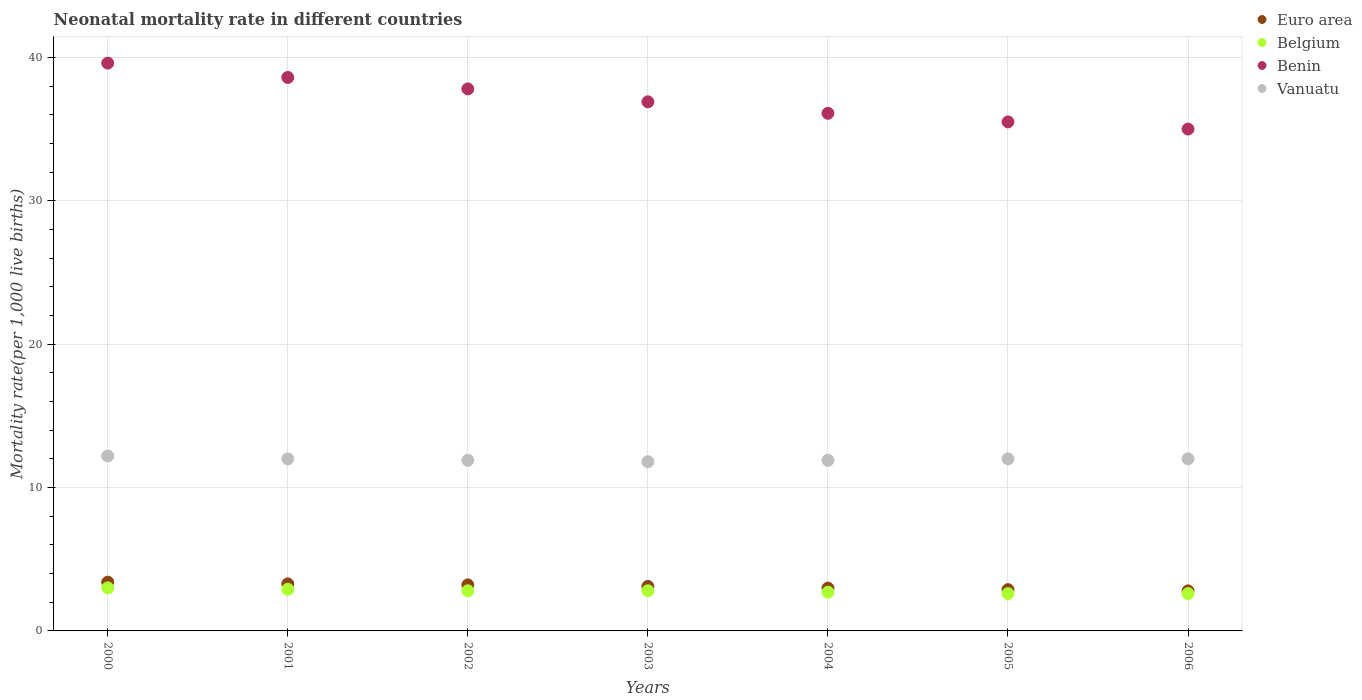What is the neonatal mortality rate in Benin in 2006?
Make the answer very short. 35. Across all years, what is the maximum neonatal mortality rate in Belgium?
Offer a terse response. 3. Across all years, what is the minimum neonatal mortality rate in Euro area?
Give a very brief answer. 2.79. What is the total neonatal mortality rate in Vanuatu in the graph?
Your answer should be compact. 83.8. What is the difference between the neonatal mortality rate in Benin in 2003 and that in 2004?
Provide a short and direct response. 0.8. What is the difference between the neonatal mortality rate in Belgium in 2004 and the neonatal mortality rate in Euro area in 2001?
Your answer should be very brief. -0.58. What is the average neonatal mortality rate in Benin per year?
Make the answer very short. 37.07. In the year 2002, what is the difference between the neonatal mortality rate in Belgium and neonatal mortality rate in Euro area?
Provide a succinct answer. -0.41. In how many years, is the neonatal mortality rate in Benin greater than 28?
Keep it short and to the point. 7. What is the ratio of the neonatal mortality rate in Belgium in 2001 to that in 2006?
Ensure brevity in your answer.  1.12. Is the neonatal mortality rate in Vanuatu in 2000 less than that in 2006?
Keep it short and to the point. No. Is the difference between the neonatal mortality rate in Belgium in 2003 and 2006 greater than the difference between the neonatal mortality rate in Euro area in 2003 and 2006?
Your answer should be very brief. No. What is the difference between the highest and the second highest neonatal mortality rate in Euro area?
Offer a terse response. 0.12. What is the difference between the highest and the lowest neonatal mortality rate in Belgium?
Your answer should be compact. 0.4. In how many years, is the neonatal mortality rate in Belgium greater than the average neonatal mortality rate in Belgium taken over all years?
Your answer should be very brief. 4. Is the sum of the neonatal mortality rate in Euro area in 2001 and 2003 greater than the maximum neonatal mortality rate in Vanuatu across all years?
Provide a succinct answer. No. Is it the case that in every year, the sum of the neonatal mortality rate in Vanuatu and neonatal mortality rate in Belgium  is greater than the sum of neonatal mortality rate in Benin and neonatal mortality rate in Euro area?
Keep it short and to the point. Yes. Is it the case that in every year, the sum of the neonatal mortality rate in Vanuatu and neonatal mortality rate in Benin  is greater than the neonatal mortality rate in Euro area?
Your response must be concise. Yes. Does the neonatal mortality rate in Vanuatu monotonically increase over the years?
Your response must be concise. No. Is the neonatal mortality rate in Vanuatu strictly greater than the neonatal mortality rate in Benin over the years?
Offer a terse response. No. Is the neonatal mortality rate in Euro area strictly less than the neonatal mortality rate in Belgium over the years?
Your answer should be very brief. No. How many years are there in the graph?
Offer a terse response. 7. Does the graph contain any zero values?
Offer a terse response. No. How are the legend labels stacked?
Provide a short and direct response. Vertical. What is the title of the graph?
Provide a succinct answer. Neonatal mortality rate in different countries. What is the label or title of the Y-axis?
Your answer should be compact. Mortality rate(per 1,0 live births). What is the Mortality rate(per 1,000 live births) of Euro area in 2000?
Provide a short and direct response. 3.4. What is the Mortality rate(per 1,000 live births) of Belgium in 2000?
Give a very brief answer. 3. What is the Mortality rate(per 1,000 live births) in Benin in 2000?
Keep it short and to the point. 39.6. What is the Mortality rate(per 1,000 live births) in Euro area in 2001?
Your response must be concise. 3.28. What is the Mortality rate(per 1,000 live births) in Benin in 2001?
Provide a succinct answer. 38.6. What is the Mortality rate(per 1,000 live births) in Vanuatu in 2001?
Ensure brevity in your answer.  12. What is the Mortality rate(per 1,000 live births) of Euro area in 2002?
Your answer should be very brief. 3.21. What is the Mortality rate(per 1,000 live births) in Benin in 2002?
Your response must be concise. 37.8. What is the Mortality rate(per 1,000 live births) in Euro area in 2003?
Offer a very short reply. 3.1. What is the Mortality rate(per 1,000 live births) of Belgium in 2003?
Keep it short and to the point. 2.8. What is the Mortality rate(per 1,000 live births) in Benin in 2003?
Make the answer very short. 36.9. What is the Mortality rate(per 1,000 live births) of Euro area in 2004?
Offer a terse response. 2.99. What is the Mortality rate(per 1,000 live births) of Benin in 2004?
Ensure brevity in your answer.  36.1. What is the Mortality rate(per 1,000 live births) of Vanuatu in 2004?
Offer a very short reply. 11.9. What is the Mortality rate(per 1,000 live births) of Euro area in 2005?
Provide a succinct answer. 2.88. What is the Mortality rate(per 1,000 live births) of Belgium in 2005?
Provide a short and direct response. 2.6. What is the Mortality rate(per 1,000 live births) in Benin in 2005?
Your response must be concise. 35.5. What is the Mortality rate(per 1,000 live births) in Euro area in 2006?
Offer a terse response. 2.79. What is the Mortality rate(per 1,000 live births) of Benin in 2006?
Your answer should be very brief. 35. Across all years, what is the maximum Mortality rate(per 1,000 live births) in Euro area?
Keep it short and to the point. 3.4. Across all years, what is the maximum Mortality rate(per 1,000 live births) in Benin?
Give a very brief answer. 39.6. Across all years, what is the minimum Mortality rate(per 1,000 live births) of Euro area?
Provide a short and direct response. 2.79. Across all years, what is the minimum Mortality rate(per 1,000 live births) of Benin?
Provide a short and direct response. 35. What is the total Mortality rate(per 1,000 live births) of Euro area in the graph?
Ensure brevity in your answer.  21.65. What is the total Mortality rate(per 1,000 live births) in Benin in the graph?
Your answer should be compact. 259.5. What is the total Mortality rate(per 1,000 live births) in Vanuatu in the graph?
Your answer should be compact. 83.8. What is the difference between the Mortality rate(per 1,000 live births) in Euro area in 2000 and that in 2001?
Offer a very short reply. 0.12. What is the difference between the Mortality rate(per 1,000 live births) of Belgium in 2000 and that in 2001?
Your answer should be very brief. 0.1. What is the difference between the Mortality rate(per 1,000 live births) of Benin in 2000 and that in 2001?
Give a very brief answer. 1. What is the difference between the Mortality rate(per 1,000 live births) of Vanuatu in 2000 and that in 2001?
Offer a very short reply. 0.2. What is the difference between the Mortality rate(per 1,000 live births) in Euro area in 2000 and that in 2002?
Keep it short and to the point. 0.19. What is the difference between the Mortality rate(per 1,000 live births) of Belgium in 2000 and that in 2002?
Your answer should be very brief. 0.2. What is the difference between the Mortality rate(per 1,000 live births) in Benin in 2000 and that in 2002?
Keep it short and to the point. 1.8. What is the difference between the Mortality rate(per 1,000 live births) of Vanuatu in 2000 and that in 2002?
Give a very brief answer. 0.3. What is the difference between the Mortality rate(per 1,000 live births) in Euro area in 2000 and that in 2003?
Your answer should be compact. 0.3. What is the difference between the Mortality rate(per 1,000 live births) of Benin in 2000 and that in 2003?
Your answer should be compact. 2.7. What is the difference between the Mortality rate(per 1,000 live births) in Vanuatu in 2000 and that in 2003?
Give a very brief answer. 0.4. What is the difference between the Mortality rate(per 1,000 live births) in Euro area in 2000 and that in 2004?
Ensure brevity in your answer.  0.42. What is the difference between the Mortality rate(per 1,000 live births) of Benin in 2000 and that in 2004?
Keep it short and to the point. 3.5. What is the difference between the Mortality rate(per 1,000 live births) in Euro area in 2000 and that in 2005?
Make the answer very short. 0.53. What is the difference between the Mortality rate(per 1,000 live births) of Belgium in 2000 and that in 2005?
Ensure brevity in your answer.  0.4. What is the difference between the Mortality rate(per 1,000 live births) in Euro area in 2000 and that in 2006?
Provide a succinct answer. 0.61. What is the difference between the Mortality rate(per 1,000 live births) in Belgium in 2000 and that in 2006?
Provide a succinct answer. 0.4. What is the difference between the Mortality rate(per 1,000 live births) of Vanuatu in 2000 and that in 2006?
Provide a succinct answer. 0.2. What is the difference between the Mortality rate(per 1,000 live births) in Euro area in 2001 and that in 2002?
Your answer should be very brief. 0.07. What is the difference between the Mortality rate(per 1,000 live births) in Euro area in 2001 and that in 2003?
Give a very brief answer. 0.18. What is the difference between the Mortality rate(per 1,000 live births) of Benin in 2001 and that in 2003?
Provide a succinct answer. 1.7. What is the difference between the Mortality rate(per 1,000 live births) of Vanuatu in 2001 and that in 2003?
Provide a short and direct response. 0.2. What is the difference between the Mortality rate(per 1,000 live births) of Euro area in 2001 and that in 2004?
Give a very brief answer. 0.3. What is the difference between the Mortality rate(per 1,000 live births) of Belgium in 2001 and that in 2004?
Your response must be concise. 0.2. What is the difference between the Mortality rate(per 1,000 live births) of Benin in 2001 and that in 2004?
Offer a terse response. 2.5. What is the difference between the Mortality rate(per 1,000 live births) in Vanuatu in 2001 and that in 2004?
Offer a very short reply. 0.1. What is the difference between the Mortality rate(per 1,000 live births) in Euro area in 2001 and that in 2005?
Keep it short and to the point. 0.41. What is the difference between the Mortality rate(per 1,000 live births) in Benin in 2001 and that in 2005?
Provide a succinct answer. 3.1. What is the difference between the Mortality rate(per 1,000 live births) of Euro area in 2001 and that in 2006?
Your answer should be compact. 0.49. What is the difference between the Mortality rate(per 1,000 live births) in Belgium in 2001 and that in 2006?
Keep it short and to the point. 0.3. What is the difference between the Mortality rate(per 1,000 live births) of Vanuatu in 2001 and that in 2006?
Keep it short and to the point. 0. What is the difference between the Mortality rate(per 1,000 live births) in Euro area in 2002 and that in 2003?
Ensure brevity in your answer.  0.11. What is the difference between the Mortality rate(per 1,000 live births) in Benin in 2002 and that in 2003?
Offer a very short reply. 0.9. What is the difference between the Mortality rate(per 1,000 live births) of Vanuatu in 2002 and that in 2003?
Your answer should be compact. 0.1. What is the difference between the Mortality rate(per 1,000 live births) in Euro area in 2002 and that in 2004?
Keep it short and to the point. 0.22. What is the difference between the Mortality rate(per 1,000 live births) in Benin in 2002 and that in 2004?
Make the answer very short. 1.7. What is the difference between the Mortality rate(per 1,000 live births) in Vanuatu in 2002 and that in 2004?
Give a very brief answer. 0. What is the difference between the Mortality rate(per 1,000 live births) of Euro area in 2002 and that in 2005?
Make the answer very short. 0.33. What is the difference between the Mortality rate(per 1,000 live births) in Benin in 2002 and that in 2005?
Ensure brevity in your answer.  2.3. What is the difference between the Mortality rate(per 1,000 live births) in Euro area in 2002 and that in 2006?
Ensure brevity in your answer.  0.42. What is the difference between the Mortality rate(per 1,000 live births) of Benin in 2002 and that in 2006?
Make the answer very short. 2.8. What is the difference between the Mortality rate(per 1,000 live births) in Vanuatu in 2002 and that in 2006?
Offer a terse response. -0.1. What is the difference between the Mortality rate(per 1,000 live births) in Euro area in 2003 and that in 2004?
Provide a succinct answer. 0.12. What is the difference between the Mortality rate(per 1,000 live births) of Euro area in 2003 and that in 2005?
Your answer should be very brief. 0.23. What is the difference between the Mortality rate(per 1,000 live births) of Vanuatu in 2003 and that in 2005?
Your answer should be compact. -0.2. What is the difference between the Mortality rate(per 1,000 live births) in Euro area in 2003 and that in 2006?
Keep it short and to the point. 0.31. What is the difference between the Mortality rate(per 1,000 live births) in Euro area in 2004 and that in 2005?
Give a very brief answer. 0.11. What is the difference between the Mortality rate(per 1,000 live births) in Belgium in 2004 and that in 2005?
Make the answer very short. 0.1. What is the difference between the Mortality rate(per 1,000 live births) of Vanuatu in 2004 and that in 2005?
Ensure brevity in your answer.  -0.1. What is the difference between the Mortality rate(per 1,000 live births) in Euro area in 2004 and that in 2006?
Give a very brief answer. 0.19. What is the difference between the Mortality rate(per 1,000 live births) of Belgium in 2004 and that in 2006?
Offer a terse response. 0.1. What is the difference between the Mortality rate(per 1,000 live births) in Benin in 2004 and that in 2006?
Offer a terse response. 1.1. What is the difference between the Mortality rate(per 1,000 live births) in Euro area in 2005 and that in 2006?
Offer a terse response. 0.08. What is the difference between the Mortality rate(per 1,000 live births) in Benin in 2005 and that in 2006?
Offer a terse response. 0.5. What is the difference between the Mortality rate(per 1,000 live births) in Vanuatu in 2005 and that in 2006?
Provide a succinct answer. 0. What is the difference between the Mortality rate(per 1,000 live births) in Euro area in 2000 and the Mortality rate(per 1,000 live births) in Belgium in 2001?
Make the answer very short. 0.5. What is the difference between the Mortality rate(per 1,000 live births) in Euro area in 2000 and the Mortality rate(per 1,000 live births) in Benin in 2001?
Give a very brief answer. -35.2. What is the difference between the Mortality rate(per 1,000 live births) in Euro area in 2000 and the Mortality rate(per 1,000 live births) in Vanuatu in 2001?
Your answer should be compact. -8.6. What is the difference between the Mortality rate(per 1,000 live births) of Belgium in 2000 and the Mortality rate(per 1,000 live births) of Benin in 2001?
Keep it short and to the point. -35.6. What is the difference between the Mortality rate(per 1,000 live births) of Benin in 2000 and the Mortality rate(per 1,000 live births) of Vanuatu in 2001?
Provide a short and direct response. 27.6. What is the difference between the Mortality rate(per 1,000 live births) of Euro area in 2000 and the Mortality rate(per 1,000 live births) of Belgium in 2002?
Provide a succinct answer. 0.6. What is the difference between the Mortality rate(per 1,000 live births) of Euro area in 2000 and the Mortality rate(per 1,000 live births) of Benin in 2002?
Give a very brief answer. -34.4. What is the difference between the Mortality rate(per 1,000 live births) in Euro area in 2000 and the Mortality rate(per 1,000 live births) in Vanuatu in 2002?
Offer a very short reply. -8.5. What is the difference between the Mortality rate(per 1,000 live births) in Belgium in 2000 and the Mortality rate(per 1,000 live births) in Benin in 2002?
Give a very brief answer. -34.8. What is the difference between the Mortality rate(per 1,000 live births) of Benin in 2000 and the Mortality rate(per 1,000 live births) of Vanuatu in 2002?
Keep it short and to the point. 27.7. What is the difference between the Mortality rate(per 1,000 live births) in Euro area in 2000 and the Mortality rate(per 1,000 live births) in Belgium in 2003?
Ensure brevity in your answer.  0.6. What is the difference between the Mortality rate(per 1,000 live births) in Euro area in 2000 and the Mortality rate(per 1,000 live births) in Benin in 2003?
Provide a succinct answer. -33.5. What is the difference between the Mortality rate(per 1,000 live births) of Euro area in 2000 and the Mortality rate(per 1,000 live births) of Vanuatu in 2003?
Offer a terse response. -8.4. What is the difference between the Mortality rate(per 1,000 live births) of Belgium in 2000 and the Mortality rate(per 1,000 live births) of Benin in 2003?
Make the answer very short. -33.9. What is the difference between the Mortality rate(per 1,000 live births) of Belgium in 2000 and the Mortality rate(per 1,000 live births) of Vanuatu in 2003?
Offer a very short reply. -8.8. What is the difference between the Mortality rate(per 1,000 live births) of Benin in 2000 and the Mortality rate(per 1,000 live births) of Vanuatu in 2003?
Offer a very short reply. 27.8. What is the difference between the Mortality rate(per 1,000 live births) in Euro area in 2000 and the Mortality rate(per 1,000 live births) in Belgium in 2004?
Your response must be concise. 0.7. What is the difference between the Mortality rate(per 1,000 live births) in Euro area in 2000 and the Mortality rate(per 1,000 live births) in Benin in 2004?
Your response must be concise. -32.7. What is the difference between the Mortality rate(per 1,000 live births) in Euro area in 2000 and the Mortality rate(per 1,000 live births) in Vanuatu in 2004?
Offer a very short reply. -8.5. What is the difference between the Mortality rate(per 1,000 live births) of Belgium in 2000 and the Mortality rate(per 1,000 live births) of Benin in 2004?
Give a very brief answer. -33.1. What is the difference between the Mortality rate(per 1,000 live births) in Benin in 2000 and the Mortality rate(per 1,000 live births) in Vanuatu in 2004?
Ensure brevity in your answer.  27.7. What is the difference between the Mortality rate(per 1,000 live births) in Euro area in 2000 and the Mortality rate(per 1,000 live births) in Belgium in 2005?
Your answer should be compact. 0.8. What is the difference between the Mortality rate(per 1,000 live births) of Euro area in 2000 and the Mortality rate(per 1,000 live births) of Benin in 2005?
Provide a short and direct response. -32.1. What is the difference between the Mortality rate(per 1,000 live births) of Euro area in 2000 and the Mortality rate(per 1,000 live births) of Vanuatu in 2005?
Offer a terse response. -8.6. What is the difference between the Mortality rate(per 1,000 live births) of Belgium in 2000 and the Mortality rate(per 1,000 live births) of Benin in 2005?
Offer a very short reply. -32.5. What is the difference between the Mortality rate(per 1,000 live births) of Benin in 2000 and the Mortality rate(per 1,000 live births) of Vanuatu in 2005?
Your answer should be compact. 27.6. What is the difference between the Mortality rate(per 1,000 live births) of Euro area in 2000 and the Mortality rate(per 1,000 live births) of Belgium in 2006?
Your response must be concise. 0.8. What is the difference between the Mortality rate(per 1,000 live births) of Euro area in 2000 and the Mortality rate(per 1,000 live births) of Benin in 2006?
Keep it short and to the point. -31.6. What is the difference between the Mortality rate(per 1,000 live births) of Euro area in 2000 and the Mortality rate(per 1,000 live births) of Vanuatu in 2006?
Provide a succinct answer. -8.6. What is the difference between the Mortality rate(per 1,000 live births) of Belgium in 2000 and the Mortality rate(per 1,000 live births) of Benin in 2006?
Keep it short and to the point. -32. What is the difference between the Mortality rate(per 1,000 live births) of Belgium in 2000 and the Mortality rate(per 1,000 live births) of Vanuatu in 2006?
Provide a short and direct response. -9. What is the difference between the Mortality rate(per 1,000 live births) of Benin in 2000 and the Mortality rate(per 1,000 live births) of Vanuatu in 2006?
Keep it short and to the point. 27.6. What is the difference between the Mortality rate(per 1,000 live births) in Euro area in 2001 and the Mortality rate(per 1,000 live births) in Belgium in 2002?
Give a very brief answer. 0.48. What is the difference between the Mortality rate(per 1,000 live births) of Euro area in 2001 and the Mortality rate(per 1,000 live births) of Benin in 2002?
Offer a terse response. -34.52. What is the difference between the Mortality rate(per 1,000 live births) of Euro area in 2001 and the Mortality rate(per 1,000 live births) of Vanuatu in 2002?
Make the answer very short. -8.62. What is the difference between the Mortality rate(per 1,000 live births) of Belgium in 2001 and the Mortality rate(per 1,000 live births) of Benin in 2002?
Your response must be concise. -34.9. What is the difference between the Mortality rate(per 1,000 live births) in Benin in 2001 and the Mortality rate(per 1,000 live births) in Vanuatu in 2002?
Keep it short and to the point. 26.7. What is the difference between the Mortality rate(per 1,000 live births) of Euro area in 2001 and the Mortality rate(per 1,000 live births) of Belgium in 2003?
Ensure brevity in your answer.  0.48. What is the difference between the Mortality rate(per 1,000 live births) of Euro area in 2001 and the Mortality rate(per 1,000 live births) of Benin in 2003?
Your answer should be very brief. -33.62. What is the difference between the Mortality rate(per 1,000 live births) in Euro area in 2001 and the Mortality rate(per 1,000 live births) in Vanuatu in 2003?
Keep it short and to the point. -8.52. What is the difference between the Mortality rate(per 1,000 live births) of Belgium in 2001 and the Mortality rate(per 1,000 live births) of Benin in 2003?
Make the answer very short. -34. What is the difference between the Mortality rate(per 1,000 live births) of Belgium in 2001 and the Mortality rate(per 1,000 live births) of Vanuatu in 2003?
Offer a very short reply. -8.9. What is the difference between the Mortality rate(per 1,000 live births) in Benin in 2001 and the Mortality rate(per 1,000 live births) in Vanuatu in 2003?
Keep it short and to the point. 26.8. What is the difference between the Mortality rate(per 1,000 live births) in Euro area in 2001 and the Mortality rate(per 1,000 live births) in Belgium in 2004?
Make the answer very short. 0.58. What is the difference between the Mortality rate(per 1,000 live births) of Euro area in 2001 and the Mortality rate(per 1,000 live births) of Benin in 2004?
Your answer should be compact. -32.82. What is the difference between the Mortality rate(per 1,000 live births) in Euro area in 2001 and the Mortality rate(per 1,000 live births) in Vanuatu in 2004?
Make the answer very short. -8.62. What is the difference between the Mortality rate(per 1,000 live births) of Belgium in 2001 and the Mortality rate(per 1,000 live births) of Benin in 2004?
Offer a very short reply. -33.2. What is the difference between the Mortality rate(per 1,000 live births) of Belgium in 2001 and the Mortality rate(per 1,000 live births) of Vanuatu in 2004?
Provide a short and direct response. -9. What is the difference between the Mortality rate(per 1,000 live births) in Benin in 2001 and the Mortality rate(per 1,000 live births) in Vanuatu in 2004?
Your answer should be very brief. 26.7. What is the difference between the Mortality rate(per 1,000 live births) of Euro area in 2001 and the Mortality rate(per 1,000 live births) of Belgium in 2005?
Your response must be concise. 0.68. What is the difference between the Mortality rate(per 1,000 live births) of Euro area in 2001 and the Mortality rate(per 1,000 live births) of Benin in 2005?
Your answer should be compact. -32.22. What is the difference between the Mortality rate(per 1,000 live births) of Euro area in 2001 and the Mortality rate(per 1,000 live births) of Vanuatu in 2005?
Give a very brief answer. -8.72. What is the difference between the Mortality rate(per 1,000 live births) in Belgium in 2001 and the Mortality rate(per 1,000 live births) in Benin in 2005?
Provide a short and direct response. -32.6. What is the difference between the Mortality rate(per 1,000 live births) of Belgium in 2001 and the Mortality rate(per 1,000 live births) of Vanuatu in 2005?
Offer a very short reply. -9.1. What is the difference between the Mortality rate(per 1,000 live births) of Benin in 2001 and the Mortality rate(per 1,000 live births) of Vanuatu in 2005?
Your response must be concise. 26.6. What is the difference between the Mortality rate(per 1,000 live births) of Euro area in 2001 and the Mortality rate(per 1,000 live births) of Belgium in 2006?
Ensure brevity in your answer.  0.68. What is the difference between the Mortality rate(per 1,000 live births) in Euro area in 2001 and the Mortality rate(per 1,000 live births) in Benin in 2006?
Make the answer very short. -31.72. What is the difference between the Mortality rate(per 1,000 live births) in Euro area in 2001 and the Mortality rate(per 1,000 live births) in Vanuatu in 2006?
Offer a very short reply. -8.72. What is the difference between the Mortality rate(per 1,000 live births) of Belgium in 2001 and the Mortality rate(per 1,000 live births) of Benin in 2006?
Your answer should be compact. -32.1. What is the difference between the Mortality rate(per 1,000 live births) in Belgium in 2001 and the Mortality rate(per 1,000 live births) in Vanuatu in 2006?
Ensure brevity in your answer.  -9.1. What is the difference between the Mortality rate(per 1,000 live births) in Benin in 2001 and the Mortality rate(per 1,000 live births) in Vanuatu in 2006?
Give a very brief answer. 26.6. What is the difference between the Mortality rate(per 1,000 live births) in Euro area in 2002 and the Mortality rate(per 1,000 live births) in Belgium in 2003?
Your answer should be very brief. 0.41. What is the difference between the Mortality rate(per 1,000 live births) in Euro area in 2002 and the Mortality rate(per 1,000 live births) in Benin in 2003?
Give a very brief answer. -33.69. What is the difference between the Mortality rate(per 1,000 live births) of Euro area in 2002 and the Mortality rate(per 1,000 live births) of Vanuatu in 2003?
Make the answer very short. -8.59. What is the difference between the Mortality rate(per 1,000 live births) in Belgium in 2002 and the Mortality rate(per 1,000 live births) in Benin in 2003?
Ensure brevity in your answer.  -34.1. What is the difference between the Mortality rate(per 1,000 live births) of Euro area in 2002 and the Mortality rate(per 1,000 live births) of Belgium in 2004?
Ensure brevity in your answer.  0.51. What is the difference between the Mortality rate(per 1,000 live births) of Euro area in 2002 and the Mortality rate(per 1,000 live births) of Benin in 2004?
Provide a succinct answer. -32.89. What is the difference between the Mortality rate(per 1,000 live births) in Euro area in 2002 and the Mortality rate(per 1,000 live births) in Vanuatu in 2004?
Provide a succinct answer. -8.69. What is the difference between the Mortality rate(per 1,000 live births) in Belgium in 2002 and the Mortality rate(per 1,000 live births) in Benin in 2004?
Your answer should be very brief. -33.3. What is the difference between the Mortality rate(per 1,000 live births) in Belgium in 2002 and the Mortality rate(per 1,000 live births) in Vanuatu in 2004?
Keep it short and to the point. -9.1. What is the difference between the Mortality rate(per 1,000 live births) in Benin in 2002 and the Mortality rate(per 1,000 live births) in Vanuatu in 2004?
Keep it short and to the point. 25.9. What is the difference between the Mortality rate(per 1,000 live births) of Euro area in 2002 and the Mortality rate(per 1,000 live births) of Belgium in 2005?
Provide a short and direct response. 0.61. What is the difference between the Mortality rate(per 1,000 live births) of Euro area in 2002 and the Mortality rate(per 1,000 live births) of Benin in 2005?
Give a very brief answer. -32.29. What is the difference between the Mortality rate(per 1,000 live births) of Euro area in 2002 and the Mortality rate(per 1,000 live births) of Vanuatu in 2005?
Your answer should be very brief. -8.79. What is the difference between the Mortality rate(per 1,000 live births) in Belgium in 2002 and the Mortality rate(per 1,000 live births) in Benin in 2005?
Offer a very short reply. -32.7. What is the difference between the Mortality rate(per 1,000 live births) of Belgium in 2002 and the Mortality rate(per 1,000 live births) of Vanuatu in 2005?
Offer a very short reply. -9.2. What is the difference between the Mortality rate(per 1,000 live births) of Benin in 2002 and the Mortality rate(per 1,000 live births) of Vanuatu in 2005?
Keep it short and to the point. 25.8. What is the difference between the Mortality rate(per 1,000 live births) of Euro area in 2002 and the Mortality rate(per 1,000 live births) of Belgium in 2006?
Offer a terse response. 0.61. What is the difference between the Mortality rate(per 1,000 live births) of Euro area in 2002 and the Mortality rate(per 1,000 live births) of Benin in 2006?
Offer a terse response. -31.79. What is the difference between the Mortality rate(per 1,000 live births) in Euro area in 2002 and the Mortality rate(per 1,000 live births) in Vanuatu in 2006?
Keep it short and to the point. -8.79. What is the difference between the Mortality rate(per 1,000 live births) of Belgium in 2002 and the Mortality rate(per 1,000 live births) of Benin in 2006?
Offer a terse response. -32.2. What is the difference between the Mortality rate(per 1,000 live births) of Belgium in 2002 and the Mortality rate(per 1,000 live births) of Vanuatu in 2006?
Ensure brevity in your answer.  -9.2. What is the difference between the Mortality rate(per 1,000 live births) of Benin in 2002 and the Mortality rate(per 1,000 live births) of Vanuatu in 2006?
Your answer should be very brief. 25.8. What is the difference between the Mortality rate(per 1,000 live births) of Euro area in 2003 and the Mortality rate(per 1,000 live births) of Belgium in 2004?
Provide a short and direct response. 0.4. What is the difference between the Mortality rate(per 1,000 live births) in Euro area in 2003 and the Mortality rate(per 1,000 live births) in Benin in 2004?
Keep it short and to the point. -33. What is the difference between the Mortality rate(per 1,000 live births) of Euro area in 2003 and the Mortality rate(per 1,000 live births) of Vanuatu in 2004?
Make the answer very short. -8.8. What is the difference between the Mortality rate(per 1,000 live births) in Belgium in 2003 and the Mortality rate(per 1,000 live births) in Benin in 2004?
Provide a short and direct response. -33.3. What is the difference between the Mortality rate(per 1,000 live births) in Euro area in 2003 and the Mortality rate(per 1,000 live births) in Belgium in 2005?
Your answer should be very brief. 0.5. What is the difference between the Mortality rate(per 1,000 live births) in Euro area in 2003 and the Mortality rate(per 1,000 live births) in Benin in 2005?
Your answer should be very brief. -32.4. What is the difference between the Mortality rate(per 1,000 live births) of Euro area in 2003 and the Mortality rate(per 1,000 live births) of Vanuatu in 2005?
Your response must be concise. -8.9. What is the difference between the Mortality rate(per 1,000 live births) of Belgium in 2003 and the Mortality rate(per 1,000 live births) of Benin in 2005?
Your response must be concise. -32.7. What is the difference between the Mortality rate(per 1,000 live births) in Benin in 2003 and the Mortality rate(per 1,000 live births) in Vanuatu in 2005?
Offer a terse response. 24.9. What is the difference between the Mortality rate(per 1,000 live births) in Euro area in 2003 and the Mortality rate(per 1,000 live births) in Belgium in 2006?
Your response must be concise. 0.5. What is the difference between the Mortality rate(per 1,000 live births) of Euro area in 2003 and the Mortality rate(per 1,000 live births) of Benin in 2006?
Offer a terse response. -31.9. What is the difference between the Mortality rate(per 1,000 live births) in Euro area in 2003 and the Mortality rate(per 1,000 live births) in Vanuatu in 2006?
Your answer should be very brief. -8.9. What is the difference between the Mortality rate(per 1,000 live births) in Belgium in 2003 and the Mortality rate(per 1,000 live births) in Benin in 2006?
Make the answer very short. -32.2. What is the difference between the Mortality rate(per 1,000 live births) in Belgium in 2003 and the Mortality rate(per 1,000 live births) in Vanuatu in 2006?
Your answer should be compact. -9.2. What is the difference between the Mortality rate(per 1,000 live births) of Benin in 2003 and the Mortality rate(per 1,000 live births) of Vanuatu in 2006?
Ensure brevity in your answer.  24.9. What is the difference between the Mortality rate(per 1,000 live births) in Euro area in 2004 and the Mortality rate(per 1,000 live births) in Belgium in 2005?
Your response must be concise. 0.39. What is the difference between the Mortality rate(per 1,000 live births) in Euro area in 2004 and the Mortality rate(per 1,000 live births) in Benin in 2005?
Provide a short and direct response. -32.51. What is the difference between the Mortality rate(per 1,000 live births) in Euro area in 2004 and the Mortality rate(per 1,000 live births) in Vanuatu in 2005?
Keep it short and to the point. -9.01. What is the difference between the Mortality rate(per 1,000 live births) of Belgium in 2004 and the Mortality rate(per 1,000 live births) of Benin in 2005?
Your answer should be compact. -32.8. What is the difference between the Mortality rate(per 1,000 live births) of Belgium in 2004 and the Mortality rate(per 1,000 live births) of Vanuatu in 2005?
Your answer should be compact. -9.3. What is the difference between the Mortality rate(per 1,000 live births) of Benin in 2004 and the Mortality rate(per 1,000 live births) of Vanuatu in 2005?
Offer a terse response. 24.1. What is the difference between the Mortality rate(per 1,000 live births) of Euro area in 2004 and the Mortality rate(per 1,000 live births) of Belgium in 2006?
Your response must be concise. 0.39. What is the difference between the Mortality rate(per 1,000 live births) in Euro area in 2004 and the Mortality rate(per 1,000 live births) in Benin in 2006?
Provide a short and direct response. -32.01. What is the difference between the Mortality rate(per 1,000 live births) in Euro area in 2004 and the Mortality rate(per 1,000 live births) in Vanuatu in 2006?
Provide a short and direct response. -9.01. What is the difference between the Mortality rate(per 1,000 live births) of Belgium in 2004 and the Mortality rate(per 1,000 live births) of Benin in 2006?
Your answer should be compact. -32.3. What is the difference between the Mortality rate(per 1,000 live births) of Benin in 2004 and the Mortality rate(per 1,000 live births) of Vanuatu in 2006?
Your response must be concise. 24.1. What is the difference between the Mortality rate(per 1,000 live births) of Euro area in 2005 and the Mortality rate(per 1,000 live births) of Belgium in 2006?
Offer a terse response. 0.28. What is the difference between the Mortality rate(per 1,000 live births) in Euro area in 2005 and the Mortality rate(per 1,000 live births) in Benin in 2006?
Your answer should be compact. -32.12. What is the difference between the Mortality rate(per 1,000 live births) in Euro area in 2005 and the Mortality rate(per 1,000 live births) in Vanuatu in 2006?
Ensure brevity in your answer.  -9.12. What is the difference between the Mortality rate(per 1,000 live births) of Belgium in 2005 and the Mortality rate(per 1,000 live births) of Benin in 2006?
Give a very brief answer. -32.4. What is the average Mortality rate(per 1,000 live births) of Euro area per year?
Your response must be concise. 3.09. What is the average Mortality rate(per 1,000 live births) of Belgium per year?
Provide a short and direct response. 2.77. What is the average Mortality rate(per 1,000 live births) in Benin per year?
Give a very brief answer. 37.07. What is the average Mortality rate(per 1,000 live births) of Vanuatu per year?
Your answer should be compact. 11.97. In the year 2000, what is the difference between the Mortality rate(per 1,000 live births) of Euro area and Mortality rate(per 1,000 live births) of Belgium?
Provide a short and direct response. 0.4. In the year 2000, what is the difference between the Mortality rate(per 1,000 live births) in Euro area and Mortality rate(per 1,000 live births) in Benin?
Ensure brevity in your answer.  -36.2. In the year 2000, what is the difference between the Mortality rate(per 1,000 live births) of Euro area and Mortality rate(per 1,000 live births) of Vanuatu?
Keep it short and to the point. -8.8. In the year 2000, what is the difference between the Mortality rate(per 1,000 live births) in Belgium and Mortality rate(per 1,000 live births) in Benin?
Offer a very short reply. -36.6. In the year 2000, what is the difference between the Mortality rate(per 1,000 live births) in Benin and Mortality rate(per 1,000 live births) in Vanuatu?
Make the answer very short. 27.4. In the year 2001, what is the difference between the Mortality rate(per 1,000 live births) of Euro area and Mortality rate(per 1,000 live births) of Belgium?
Your answer should be compact. 0.38. In the year 2001, what is the difference between the Mortality rate(per 1,000 live births) of Euro area and Mortality rate(per 1,000 live births) of Benin?
Give a very brief answer. -35.32. In the year 2001, what is the difference between the Mortality rate(per 1,000 live births) in Euro area and Mortality rate(per 1,000 live births) in Vanuatu?
Offer a very short reply. -8.72. In the year 2001, what is the difference between the Mortality rate(per 1,000 live births) in Belgium and Mortality rate(per 1,000 live births) in Benin?
Offer a very short reply. -35.7. In the year 2001, what is the difference between the Mortality rate(per 1,000 live births) in Benin and Mortality rate(per 1,000 live births) in Vanuatu?
Offer a terse response. 26.6. In the year 2002, what is the difference between the Mortality rate(per 1,000 live births) in Euro area and Mortality rate(per 1,000 live births) in Belgium?
Give a very brief answer. 0.41. In the year 2002, what is the difference between the Mortality rate(per 1,000 live births) of Euro area and Mortality rate(per 1,000 live births) of Benin?
Your answer should be very brief. -34.59. In the year 2002, what is the difference between the Mortality rate(per 1,000 live births) of Euro area and Mortality rate(per 1,000 live births) of Vanuatu?
Give a very brief answer. -8.69. In the year 2002, what is the difference between the Mortality rate(per 1,000 live births) in Belgium and Mortality rate(per 1,000 live births) in Benin?
Offer a terse response. -35. In the year 2002, what is the difference between the Mortality rate(per 1,000 live births) of Benin and Mortality rate(per 1,000 live births) of Vanuatu?
Provide a short and direct response. 25.9. In the year 2003, what is the difference between the Mortality rate(per 1,000 live births) in Euro area and Mortality rate(per 1,000 live births) in Belgium?
Your answer should be very brief. 0.3. In the year 2003, what is the difference between the Mortality rate(per 1,000 live births) in Euro area and Mortality rate(per 1,000 live births) in Benin?
Keep it short and to the point. -33.8. In the year 2003, what is the difference between the Mortality rate(per 1,000 live births) of Euro area and Mortality rate(per 1,000 live births) of Vanuatu?
Offer a terse response. -8.7. In the year 2003, what is the difference between the Mortality rate(per 1,000 live births) in Belgium and Mortality rate(per 1,000 live births) in Benin?
Offer a terse response. -34.1. In the year 2003, what is the difference between the Mortality rate(per 1,000 live births) of Benin and Mortality rate(per 1,000 live births) of Vanuatu?
Make the answer very short. 25.1. In the year 2004, what is the difference between the Mortality rate(per 1,000 live births) of Euro area and Mortality rate(per 1,000 live births) of Belgium?
Your answer should be compact. 0.29. In the year 2004, what is the difference between the Mortality rate(per 1,000 live births) in Euro area and Mortality rate(per 1,000 live births) in Benin?
Offer a very short reply. -33.11. In the year 2004, what is the difference between the Mortality rate(per 1,000 live births) in Euro area and Mortality rate(per 1,000 live births) in Vanuatu?
Your response must be concise. -8.91. In the year 2004, what is the difference between the Mortality rate(per 1,000 live births) of Belgium and Mortality rate(per 1,000 live births) of Benin?
Give a very brief answer. -33.4. In the year 2004, what is the difference between the Mortality rate(per 1,000 live births) of Belgium and Mortality rate(per 1,000 live births) of Vanuatu?
Your answer should be very brief. -9.2. In the year 2004, what is the difference between the Mortality rate(per 1,000 live births) in Benin and Mortality rate(per 1,000 live births) in Vanuatu?
Make the answer very short. 24.2. In the year 2005, what is the difference between the Mortality rate(per 1,000 live births) of Euro area and Mortality rate(per 1,000 live births) of Belgium?
Provide a short and direct response. 0.28. In the year 2005, what is the difference between the Mortality rate(per 1,000 live births) of Euro area and Mortality rate(per 1,000 live births) of Benin?
Give a very brief answer. -32.62. In the year 2005, what is the difference between the Mortality rate(per 1,000 live births) in Euro area and Mortality rate(per 1,000 live births) in Vanuatu?
Keep it short and to the point. -9.12. In the year 2005, what is the difference between the Mortality rate(per 1,000 live births) of Belgium and Mortality rate(per 1,000 live births) of Benin?
Make the answer very short. -32.9. In the year 2006, what is the difference between the Mortality rate(per 1,000 live births) of Euro area and Mortality rate(per 1,000 live births) of Belgium?
Provide a short and direct response. 0.19. In the year 2006, what is the difference between the Mortality rate(per 1,000 live births) of Euro area and Mortality rate(per 1,000 live births) of Benin?
Provide a short and direct response. -32.21. In the year 2006, what is the difference between the Mortality rate(per 1,000 live births) in Euro area and Mortality rate(per 1,000 live births) in Vanuatu?
Make the answer very short. -9.21. In the year 2006, what is the difference between the Mortality rate(per 1,000 live births) of Belgium and Mortality rate(per 1,000 live births) of Benin?
Make the answer very short. -32.4. What is the ratio of the Mortality rate(per 1,000 live births) in Euro area in 2000 to that in 2001?
Your answer should be compact. 1.04. What is the ratio of the Mortality rate(per 1,000 live births) of Belgium in 2000 to that in 2001?
Offer a very short reply. 1.03. What is the ratio of the Mortality rate(per 1,000 live births) of Benin in 2000 to that in 2001?
Ensure brevity in your answer.  1.03. What is the ratio of the Mortality rate(per 1,000 live births) of Vanuatu in 2000 to that in 2001?
Your answer should be very brief. 1.02. What is the ratio of the Mortality rate(per 1,000 live births) of Euro area in 2000 to that in 2002?
Offer a very short reply. 1.06. What is the ratio of the Mortality rate(per 1,000 live births) in Belgium in 2000 to that in 2002?
Offer a very short reply. 1.07. What is the ratio of the Mortality rate(per 1,000 live births) in Benin in 2000 to that in 2002?
Provide a short and direct response. 1.05. What is the ratio of the Mortality rate(per 1,000 live births) of Vanuatu in 2000 to that in 2002?
Offer a terse response. 1.03. What is the ratio of the Mortality rate(per 1,000 live births) of Euro area in 2000 to that in 2003?
Give a very brief answer. 1.1. What is the ratio of the Mortality rate(per 1,000 live births) in Belgium in 2000 to that in 2003?
Your answer should be compact. 1.07. What is the ratio of the Mortality rate(per 1,000 live births) in Benin in 2000 to that in 2003?
Your answer should be very brief. 1.07. What is the ratio of the Mortality rate(per 1,000 live births) in Vanuatu in 2000 to that in 2003?
Keep it short and to the point. 1.03. What is the ratio of the Mortality rate(per 1,000 live births) in Euro area in 2000 to that in 2004?
Offer a very short reply. 1.14. What is the ratio of the Mortality rate(per 1,000 live births) of Belgium in 2000 to that in 2004?
Make the answer very short. 1.11. What is the ratio of the Mortality rate(per 1,000 live births) in Benin in 2000 to that in 2004?
Make the answer very short. 1.1. What is the ratio of the Mortality rate(per 1,000 live births) in Vanuatu in 2000 to that in 2004?
Your answer should be compact. 1.03. What is the ratio of the Mortality rate(per 1,000 live births) of Euro area in 2000 to that in 2005?
Offer a very short reply. 1.18. What is the ratio of the Mortality rate(per 1,000 live births) in Belgium in 2000 to that in 2005?
Keep it short and to the point. 1.15. What is the ratio of the Mortality rate(per 1,000 live births) in Benin in 2000 to that in 2005?
Your answer should be compact. 1.12. What is the ratio of the Mortality rate(per 1,000 live births) in Vanuatu in 2000 to that in 2005?
Provide a succinct answer. 1.02. What is the ratio of the Mortality rate(per 1,000 live births) in Euro area in 2000 to that in 2006?
Your response must be concise. 1.22. What is the ratio of the Mortality rate(per 1,000 live births) in Belgium in 2000 to that in 2006?
Make the answer very short. 1.15. What is the ratio of the Mortality rate(per 1,000 live births) in Benin in 2000 to that in 2006?
Keep it short and to the point. 1.13. What is the ratio of the Mortality rate(per 1,000 live births) in Vanuatu in 2000 to that in 2006?
Offer a terse response. 1.02. What is the ratio of the Mortality rate(per 1,000 live births) of Euro area in 2001 to that in 2002?
Provide a short and direct response. 1.02. What is the ratio of the Mortality rate(per 1,000 live births) of Belgium in 2001 to that in 2002?
Offer a terse response. 1.04. What is the ratio of the Mortality rate(per 1,000 live births) in Benin in 2001 to that in 2002?
Offer a very short reply. 1.02. What is the ratio of the Mortality rate(per 1,000 live births) in Vanuatu in 2001 to that in 2002?
Your response must be concise. 1.01. What is the ratio of the Mortality rate(per 1,000 live births) of Euro area in 2001 to that in 2003?
Your answer should be compact. 1.06. What is the ratio of the Mortality rate(per 1,000 live births) of Belgium in 2001 to that in 2003?
Your answer should be very brief. 1.04. What is the ratio of the Mortality rate(per 1,000 live births) in Benin in 2001 to that in 2003?
Offer a very short reply. 1.05. What is the ratio of the Mortality rate(per 1,000 live births) in Vanuatu in 2001 to that in 2003?
Provide a short and direct response. 1.02. What is the ratio of the Mortality rate(per 1,000 live births) in Euro area in 2001 to that in 2004?
Give a very brief answer. 1.1. What is the ratio of the Mortality rate(per 1,000 live births) of Belgium in 2001 to that in 2004?
Make the answer very short. 1.07. What is the ratio of the Mortality rate(per 1,000 live births) of Benin in 2001 to that in 2004?
Your response must be concise. 1.07. What is the ratio of the Mortality rate(per 1,000 live births) in Vanuatu in 2001 to that in 2004?
Offer a very short reply. 1.01. What is the ratio of the Mortality rate(per 1,000 live births) in Euro area in 2001 to that in 2005?
Your answer should be very brief. 1.14. What is the ratio of the Mortality rate(per 1,000 live births) of Belgium in 2001 to that in 2005?
Keep it short and to the point. 1.12. What is the ratio of the Mortality rate(per 1,000 live births) of Benin in 2001 to that in 2005?
Offer a terse response. 1.09. What is the ratio of the Mortality rate(per 1,000 live births) of Vanuatu in 2001 to that in 2005?
Provide a succinct answer. 1. What is the ratio of the Mortality rate(per 1,000 live births) in Euro area in 2001 to that in 2006?
Offer a very short reply. 1.18. What is the ratio of the Mortality rate(per 1,000 live births) in Belgium in 2001 to that in 2006?
Offer a terse response. 1.12. What is the ratio of the Mortality rate(per 1,000 live births) in Benin in 2001 to that in 2006?
Make the answer very short. 1.1. What is the ratio of the Mortality rate(per 1,000 live births) of Vanuatu in 2001 to that in 2006?
Provide a short and direct response. 1. What is the ratio of the Mortality rate(per 1,000 live births) of Euro area in 2002 to that in 2003?
Your answer should be compact. 1.03. What is the ratio of the Mortality rate(per 1,000 live births) of Belgium in 2002 to that in 2003?
Provide a short and direct response. 1. What is the ratio of the Mortality rate(per 1,000 live births) in Benin in 2002 to that in 2003?
Make the answer very short. 1.02. What is the ratio of the Mortality rate(per 1,000 live births) of Vanuatu in 2002 to that in 2003?
Your response must be concise. 1.01. What is the ratio of the Mortality rate(per 1,000 live births) of Euro area in 2002 to that in 2004?
Your answer should be very brief. 1.07. What is the ratio of the Mortality rate(per 1,000 live births) of Benin in 2002 to that in 2004?
Your answer should be compact. 1.05. What is the ratio of the Mortality rate(per 1,000 live births) of Euro area in 2002 to that in 2005?
Your answer should be very brief. 1.12. What is the ratio of the Mortality rate(per 1,000 live births) in Benin in 2002 to that in 2005?
Your answer should be compact. 1.06. What is the ratio of the Mortality rate(per 1,000 live births) in Vanuatu in 2002 to that in 2005?
Provide a succinct answer. 0.99. What is the ratio of the Mortality rate(per 1,000 live births) of Euro area in 2002 to that in 2006?
Give a very brief answer. 1.15. What is the ratio of the Mortality rate(per 1,000 live births) in Belgium in 2002 to that in 2006?
Offer a terse response. 1.08. What is the ratio of the Mortality rate(per 1,000 live births) in Benin in 2002 to that in 2006?
Make the answer very short. 1.08. What is the ratio of the Mortality rate(per 1,000 live births) of Euro area in 2003 to that in 2004?
Offer a terse response. 1.04. What is the ratio of the Mortality rate(per 1,000 live births) of Belgium in 2003 to that in 2004?
Offer a terse response. 1.04. What is the ratio of the Mortality rate(per 1,000 live births) of Benin in 2003 to that in 2004?
Provide a succinct answer. 1.02. What is the ratio of the Mortality rate(per 1,000 live births) in Euro area in 2003 to that in 2005?
Your answer should be very brief. 1.08. What is the ratio of the Mortality rate(per 1,000 live births) of Belgium in 2003 to that in 2005?
Give a very brief answer. 1.08. What is the ratio of the Mortality rate(per 1,000 live births) of Benin in 2003 to that in 2005?
Keep it short and to the point. 1.04. What is the ratio of the Mortality rate(per 1,000 live births) in Vanuatu in 2003 to that in 2005?
Provide a succinct answer. 0.98. What is the ratio of the Mortality rate(per 1,000 live births) in Euro area in 2003 to that in 2006?
Provide a short and direct response. 1.11. What is the ratio of the Mortality rate(per 1,000 live births) in Benin in 2003 to that in 2006?
Your answer should be compact. 1.05. What is the ratio of the Mortality rate(per 1,000 live births) in Vanuatu in 2003 to that in 2006?
Provide a succinct answer. 0.98. What is the ratio of the Mortality rate(per 1,000 live births) in Euro area in 2004 to that in 2005?
Your response must be concise. 1.04. What is the ratio of the Mortality rate(per 1,000 live births) in Benin in 2004 to that in 2005?
Keep it short and to the point. 1.02. What is the ratio of the Mortality rate(per 1,000 live births) of Euro area in 2004 to that in 2006?
Provide a succinct answer. 1.07. What is the ratio of the Mortality rate(per 1,000 live births) in Benin in 2004 to that in 2006?
Provide a short and direct response. 1.03. What is the ratio of the Mortality rate(per 1,000 live births) of Euro area in 2005 to that in 2006?
Your answer should be very brief. 1.03. What is the ratio of the Mortality rate(per 1,000 live births) of Benin in 2005 to that in 2006?
Ensure brevity in your answer.  1.01. What is the ratio of the Mortality rate(per 1,000 live births) of Vanuatu in 2005 to that in 2006?
Provide a short and direct response. 1. What is the difference between the highest and the second highest Mortality rate(per 1,000 live births) in Euro area?
Provide a succinct answer. 0.12. What is the difference between the highest and the second highest Mortality rate(per 1,000 live births) in Belgium?
Make the answer very short. 0.1. What is the difference between the highest and the second highest Mortality rate(per 1,000 live births) of Benin?
Ensure brevity in your answer.  1. What is the difference between the highest and the lowest Mortality rate(per 1,000 live births) of Euro area?
Keep it short and to the point. 0.61. What is the difference between the highest and the lowest Mortality rate(per 1,000 live births) of Belgium?
Provide a succinct answer. 0.4. What is the difference between the highest and the lowest Mortality rate(per 1,000 live births) in Vanuatu?
Ensure brevity in your answer.  0.4. 